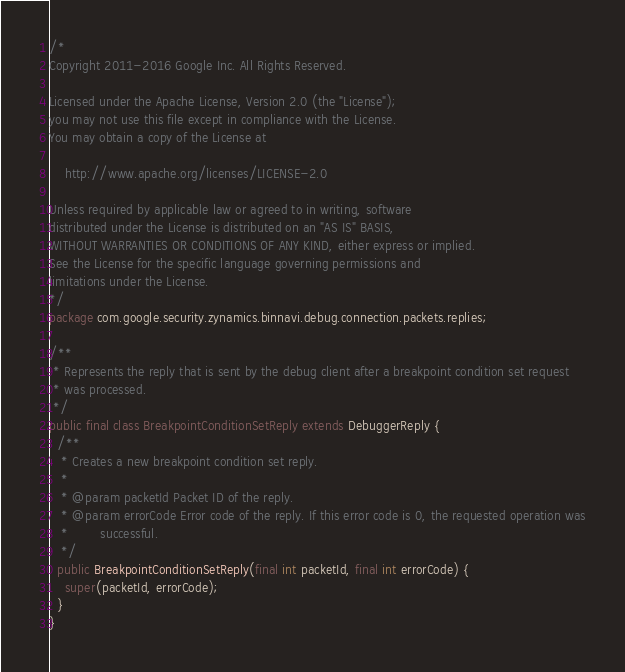Convert code to text. <code><loc_0><loc_0><loc_500><loc_500><_Java_>/*
Copyright 2011-2016 Google Inc. All Rights Reserved.

Licensed under the Apache License, Version 2.0 (the "License");
you may not use this file except in compliance with the License.
You may obtain a copy of the License at

    http://www.apache.org/licenses/LICENSE-2.0

Unless required by applicable law or agreed to in writing, software
distributed under the License is distributed on an "AS IS" BASIS,
WITHOUT WARRANTIES OR CONDITIONS OF ANY KIND, either express or implied.
See the License for the specific language governing permissions and
limitations under the License.
*/
package com.google.security.zynamics.binnavi.debug.connection.packets.replies;

/**
 * Represents the reply that is sent by the debug client after a breakpoint condition set request
 * was processed.
 */
public final class BreakpointConditionSetReply extends DebuggerReply {
  /**
   * Creates a new breakpoint condition set reply.
   *
   * @param packetId Packet ID of the reply.
   * @param errorCode Error code of the reply. If this error code is 0, the requested operation was
   *        successful.
   */
  public BreakpointConditionSetReply(final int packetId, final int errorCode) {
    super(packetId, errorCode);
  }
}
</code> 